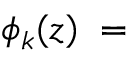Convert formula to latex. <formula><loc_0><loc_0><loc_500><loc_500>\phi _ { k } ( z ) \, = \,</formula> 